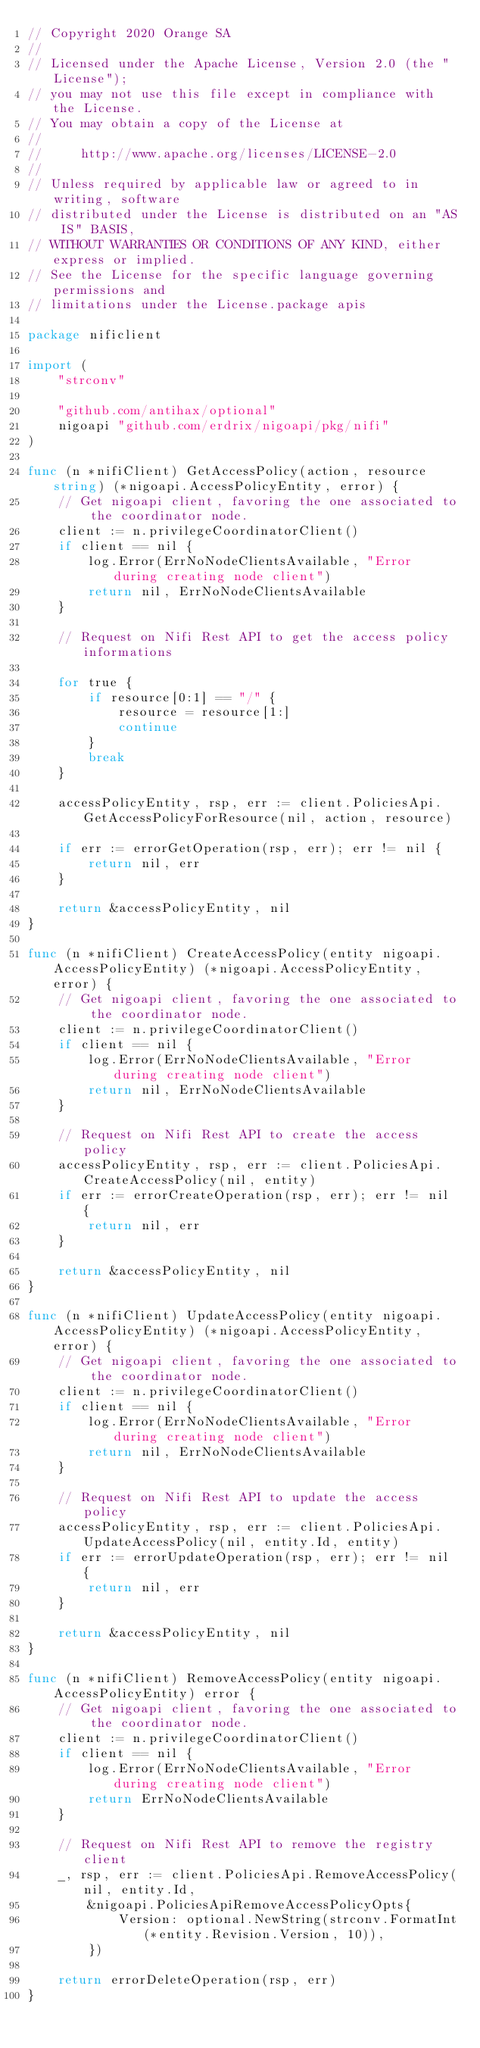Convert code to text. <code><loc_0><loc_0><loc_500><loc_500><_Go_>// Copyright 2020 Orange SA
//
// Licensed under the Apache License, Version 2.0 (the "License");
// you may not use this file except in compliance with the License.
// You may obtain a copy of the License at
//
//     http://www.apache.org/licenses/LICENSE-2.0
//
// Unless required by applicable law or agreed to in writing, software
// distributed under the License is distributed on an "AS IS" BASIS,
// WITHOUT WARRANTIES OR CONDITIONS OF ANY KIND, either express or implied.
// See the License for the specific language governing permissions and
// limitations under the License.package apis

package nificlient

import (
	"strconv"

	"github.com/antihax/optional"
	nigoapi "github.com/erdrix/nigoapi/pkg/nifi"
)

func (n *nifiClient) GetAccessPolicy(action, resource string) (*nigoapi.AccessPolicyEntity, error) {
	// Get nigoapi client, favoring the one associated to the coordinator node.
	client := n.privilegeCoordinatorClient()
	if client == nil {
		log.Error(ErrNoNodeClientsAvailable, "Error during creating node client")
		return nil, ErrNoNodeClientsAvailable
	}

	// Request on Nifi Rest API to get the access policy informations

	for true {
		if resource[0:1] == "/" {
			resource = resource[1:]
			continue
		}
		break
	}

	accessPolicyEntity, rsp, err := client.PoliciesApi.GetAccessPolicyForResource(nil, action, resource)

	if err := errorGetOperation(rsp, err); err != nil {
		return nil, err
	}

	return &accessPolicyEntity, nil
}

func (n *nifiClient) CreateAccessPolicy(entity nigoapi.AccessPolicyEntity) (*nigoapi.AccessPolicyEntity, error) {
	// Get nigoapi client, favoring the one associated to the coordinator node.
	client := n.privilegeCoordinatorClient()
	if client == nil {
		log.Error(ErrNoNodeClientsAvailable, "Error during creating node client")
		return nil, ErrNoNodeClientsAvailable
	}

	// Request on Nifi Rest API to create the access policy
	accessPolicyEntity, rsp, err := client.PoliciesApi.CreateAccessPolicy(nil, entity)
	if err := errorCreateOperation(rsp, err); err != nil {
		return nil, err
	}

	return &accessPolicyEntity, nil
}

func (n *nifiClient) UpdateAccessPolicy(entity nigoapi.AccessPolicyEntity) (*nigoapi.AccessPolicyEntity, error) {
	// Get nigoapi client, favoring the one associated to the coordinator node.
	client := n.privilegeCoordinatorClient()
	if client == nil {
		log.Error(ErrNoNodeClientsAvailable, "Error during creating node client")
		return nil, ErrNoNodeClientsAvailable
	}

	// Request on Nifi Rest API to update the access policy
	accessPolicyEntity, rsp, err := client.PoliciesApi.UpdateAccessPolicy(nil, entity.Id, entity)
	if err := errorUpdateOperation(rsp, err); err != nil {
		return nil, err
	}

	return &accessPolicyEntity, nil
}

func (n *nifiClient) RemoveAccessPolicy(entity nigoapi.AccessPolicyEntity) error {
	// Get nigoapi client, favoring the one associated to the coordinator node.
	client := n.privilegeCoordinatorClient()
	if client == nil {
		log.Error(ErrNoNodeClientsAvailable, "Error during creating node client")
		return ErrNoNodeClientsAvailable
	}

	// Request on Nifi Rest API to remove the registry client
	_, rsp, err := client.PoliciesApi.RemoveAccessPolicy(nil, entity.Id,
		&nigoapi.PoliciesApiRemoveAccessPolicyOpts{
			Version: optional.NewString(strconv.FormatInt(*entity.Revision.Version, 10)),
		})

	return errorDeleteOperation(rsp, err)
}
</code> 